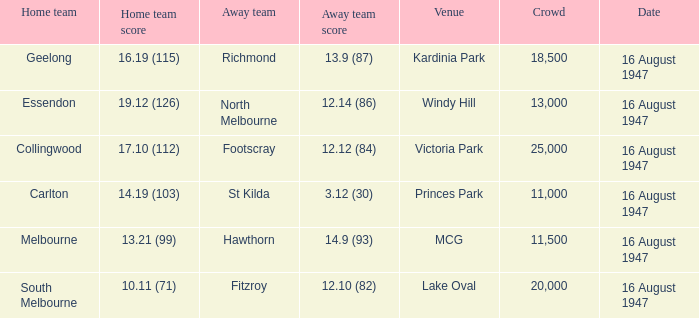What venue had footscray play at it? Victoria Park. 